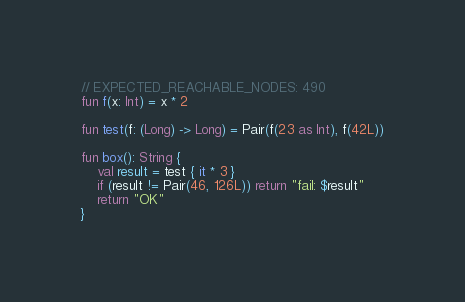Convert code to text. <code><loc_0><loc_0><loc_500><loc_500><_Kotlin_>// EXPECTED_REACHABLE_NODES: 490
fun f(x: Int) = x * 2

fun test(f: (Long) -> Long) = Pair(f(23 as Int), f(42L))

fun box(): String {
    val result = test { it * 3 }
    if (result != Pair(46, 126L)) return "fail: $result"
    return "OK"
}</code> 